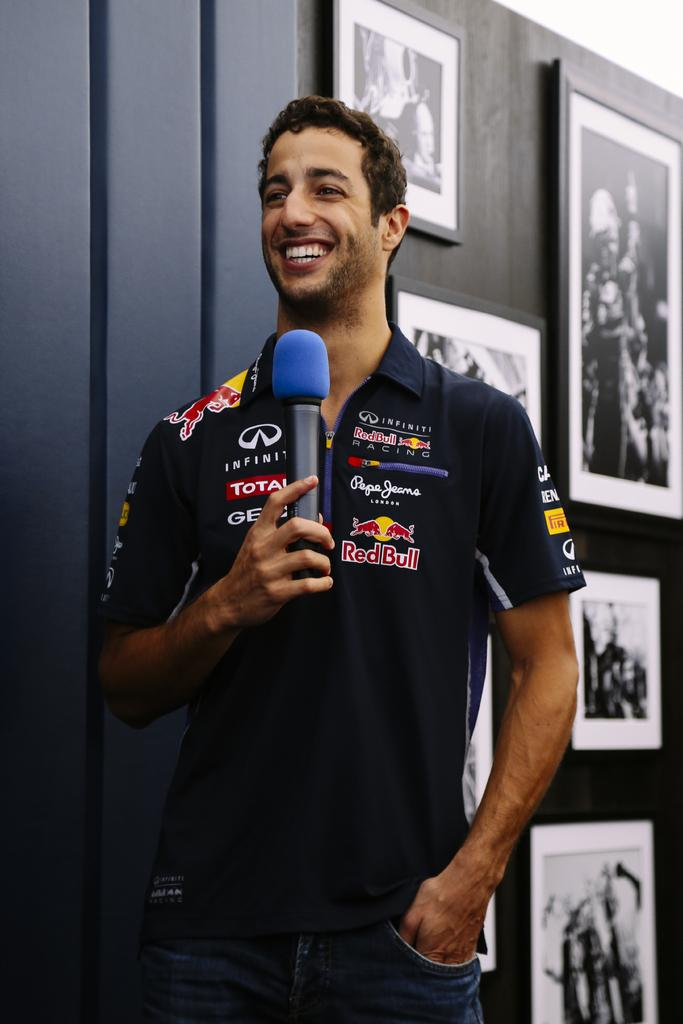<image>
Give a short and clear explanation of the subsequent image. A man wearing a shirt featuring different companies like RedBull and Infiniti smiles and holds a microphone. 